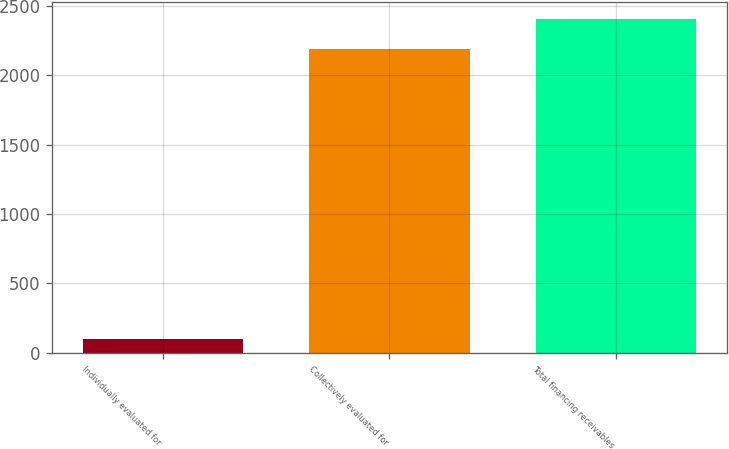Convert chart to OTSL. <chart><loc_0><loc_0><loc_500><loc_500><bar_chart><fcel>Individually evaluated for<fcel>Collectively evaluated for<fcel>Total financing receivables<nl><fcel>95<fcel>2191<fcel>2410.1<nl></chart> 